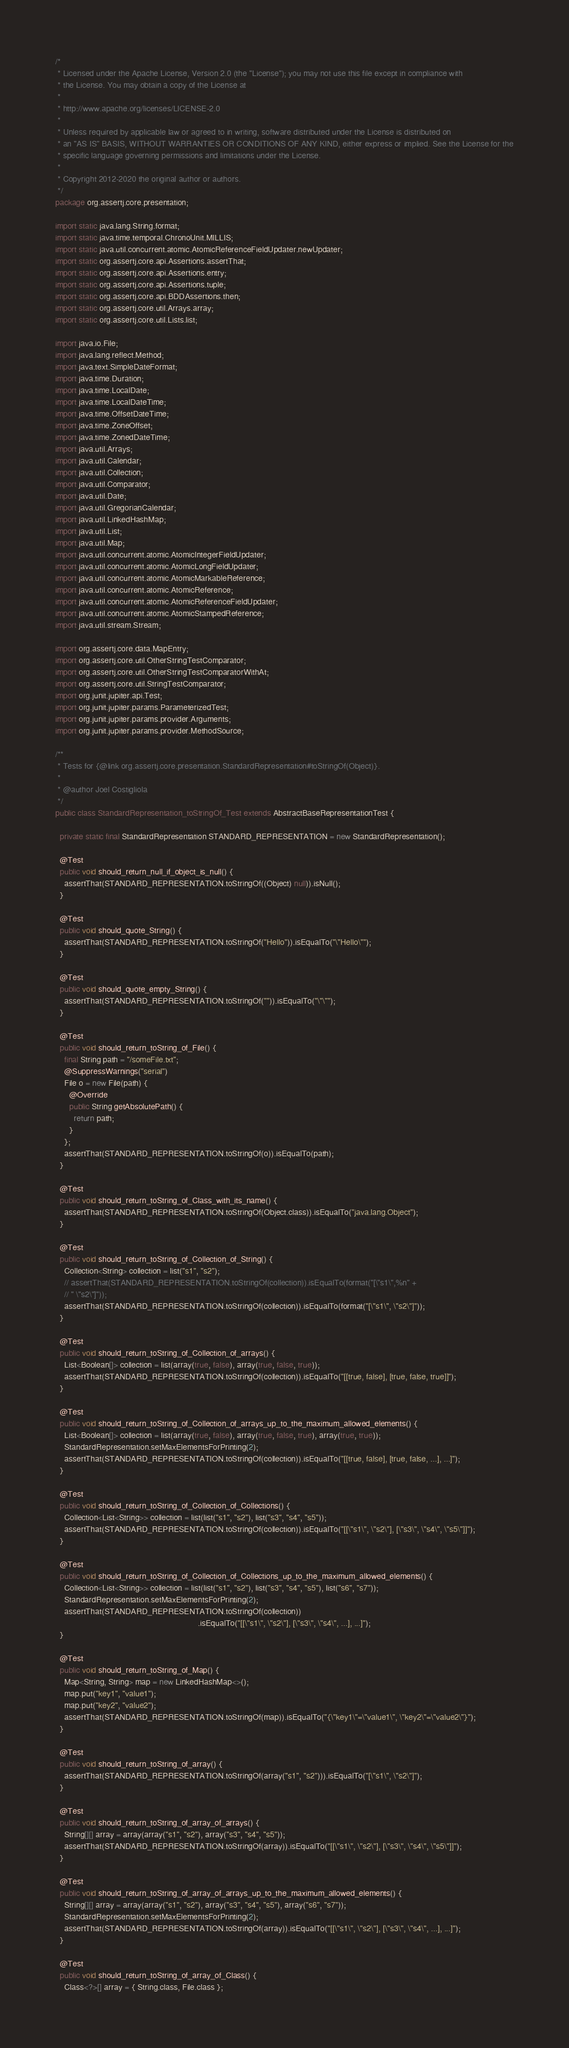<code> <loc_0><loc_0><loc_500><loc_500><_Java_>/*
 * Licensed under the Apache License, Version 2.0 (the "License"); you may not use this file except in compliance with
 * the License. You may obtain a copy of the License at
 *
 * http://www.apache.org/licenses/LICENSE-2.0
 *
 * Unless required by applicable law or agreed to in writing, software distributed under the License is distributed on
 * an "AS IS" BASIS, WITHOUT WARRANTIES OR CONDITIONS OF ANY KIND, either express or implied. See the License for the
 * specific language governing permissions and limitations under the License.
 *
 * Copyright 2012-2020 the original author or authors.
 */
package org.assertj.core.presentation;

import static java.lang.String.format;
import static java.time.temporal.ChronoUnit.MILLIS;
import static java.util.concurrent.atomic.AtomicReferenceFieldUpdater.newUpdater;
import static org.assertj.core.api.Assertions.assertThat;
import static org.assertj.core.api.Assertions.entry;
import static org.assertj.core.api.Assertions.tuple;
import static org.assertj.core.api.BDDAssertions.then;
import static org.assertj.core.util.Arrays.array;
import static org.assertj.core.util.Lists.list;

import java.io.File;
import java.lang.reflect.Method;
import java.text.SimpleDateFormat;
import java.time.Duration;
import java.time.LocalDate;
import java.time.LocalDateTime;
import java.time.OffsetDateTime;
import java.time.ZoneOffset;
import java.time.ZonedDateTime;
import java.util.Arrays;
import java.util.Calendar;
import java.util.Collection;
import java.util.Comparator;
import java.util.Date;
import java.util.GregorianCalendar;
import java.util.LinkedHashMap;
import java.util.List;
import java.util.Map;
import java.util.concurrent.atomic.AtomicIntegerFieldUpdater;
import java.util.concurrent.atomic.AtomicLongFieldUpdater;
import java.util.concurrent.atomic.AtomicMarkableReference;
import java.util.concurrent.atomic.AtomicReference;
import java.util.concurrent.atomic.AtomicReferenceFieldUpdater;
import java.util.concurrent.atomic.AtomicStampedReference;
import java.util.stream.Stream;

import org.assertj.core.data.MapEntry;
import org.assertj.core.util.OtherStringTestComparator;
import org.assertj.core.util.OtherStringTestComparatorWithAt;
import org.assertj.core.util.StringTestComparator;
import org.junit.jupiter.api.Test;
import org.junit.jupiter.params.ParameterizedTest;
import org.junit.jupiter.params.provider.Arguments;
import org.junit.jupiter.params.provider.MethodSource;

/**
 * Tests for {@link org.assertj.core.presentation.StandardRepresentation#toStringOf(Object)}.
 *
 * @author Joel Costigliola
 */
public class StandardRepresentation_toStringOf_Test extends AbstractBaseRepresentationTest {

  private static final StandardRepresentation STANDARD_REPRESENTATION = new StandardRepresentation();

  @Test
  public void should_return_null_if_object_is_null() {
    assertThat(STANDARD_REPRESENTATION.toStringOf((Object) null)).isNull();
  }

  @Test
  public void should_quote_String() {
    assertThat(STANDARD_REPRESENTATION.toStringOf("Hello")).isEqualTo("\"Hello\"");
  }

  @Test
  public void should_quote_empty_String() {
    assertThat(STANDARD_REPRESENTATION.toStringOf("")).isEqualTo("\"\"");
  }

  @Test
  public void should_return_toString_of_File() {
    final String path = "/someFile.txt";
    @SuppressWarnings("serial")
    File o = new File(path) {
      @Override
      public String getAbsolutePath() {
        return path;
      }
    };
    assertThat(STANDARD_REPRESENTATION.toStringOf(o)).isEqualTo(path);
  }

  @Test
  public void should_return_toString_of_Class_with_its_name() {
    assertThat(STANDARD_REPRESENTATION.toStringOf(Object.class)).isEqualTo("java.lang.Object");
  }

  @Test
  public void should_return_toString_of_Collection_of_String() {
    Collection<String> collection = list("s1", "s2");
    // assertThat(STANDARD_REPRESENTATION.toStringOf(collection)).isEqualTo(format("[\"s1\",%n" +
    // " \"s2\"]"));
    assertThat(STANDARD_REPRESENTATION.toStringOf(collection)).isEqualTo(format("[\"s1\", \"s2\"]"));
  }

  @Test
  public void should_return_toString_of_Collection_of_arrays() {
    List<Boolean[]> collection = list(array(true, false), array(true, false, true));
    assertThat(STANDARD_REPRESENTATION.toStringOf(collection)).isEqualTo("[[true, false], [true, false, true]]");
  }

  @Test
  public void should_return_toString_of_Collection_of_arrays_up_to_the_maximum_allowed_elements() {
    List<Boolean[]> collection = list(array(true, false), array(true, false, true), array(true, true));
    StandardRepresentation.setMaxElementsForPrinting(2);
    assertThat(STANDARD_REPRESENTATION.toStringOf(collection)).isEqualTo("[[true, false], [true, false, ...], ...]");
  }

  @Test
  public void should_return_toString_of_Collection_of_Collections() {
    Collection<List<String>> collection = list(list("s1", "s2"), list("s3", "s4", "s5"));
    assertThat(STANDARD_REPRESENTATION.toStringOf(collection)).isEqualTo("[[\"s1\", \"s2\"], [\"s3\", \"s4\", \"s5\"]]");
  }

  @Test
  public void should_return_toString_of_Collection_of_Collections_up_to_the_maximum_allowed_elements() {
    Collection<List<String>> collection = list(list("s1", "s2"), list("s3", "s4", "s5"), list("s6", "s7"));
    StandardRepresentation.setMaxElementsForPrinting(2);
    assertThat(STANDARD_REPRESENTATION.toStringOf(collection))
                                                              .isEqualTo("[[\"s1\", \"s2\"], [\"s3\", \"s4\", ...], ...]");
  }

  @Test
  public void should_return_toString_of_Map() {
    Map<String, String> map = new LinkedHashMap<>();
    map.put("key1", "value1");
    map.put("key2", "value2");
    assertThat(STANDARD_REPRESENTATION.toStringOf(map)).isEqualTo("{\"key1\"=\"value1\", \"key2\"=\"value2\"}");
  }

  @Test
  public void should_return_toString_of_array() {
    assertThat(STANDARD_REPRESENTATION.toStringOf(array("s1", "s2"))).isEqualTo("[\"s1\", \"s2\"]");
  }

  @Test
  public void should_return_toString_of_array_of_arrays() {
    String[][] array = array(array("s1", "s2"), array("s3", "s4", "s5"));
    assertThat(STANDARD_REPRESENTATION.toStringOf(array)).isEqualTo("[[\"s1\", \"s2\"], [\"s3\", \"s4\", \"s5\"]]");
  }

  @Test
  public void should_return_toString_of_array_of_arrays_up_to_the_maximum_allowed_elements() {
    String[][] array = array(array("s1", "s2"), array("s3", "s4", "s5"), array("s6", "s7"));
    StandardRepresentation.setMaxElementsForPrinting(2);
    assertThat(STANDARD_REPRESENTATION.toStringOf(array)).isEqualTo("[[\"s1\", \"s2\"], [\"s3\", \"s4\", ...], ...]");
  }

  @Test
  public void should_return_toString_of_array_of_Class() {
    Class<?>[] array = { String.class, File.class };</code> 